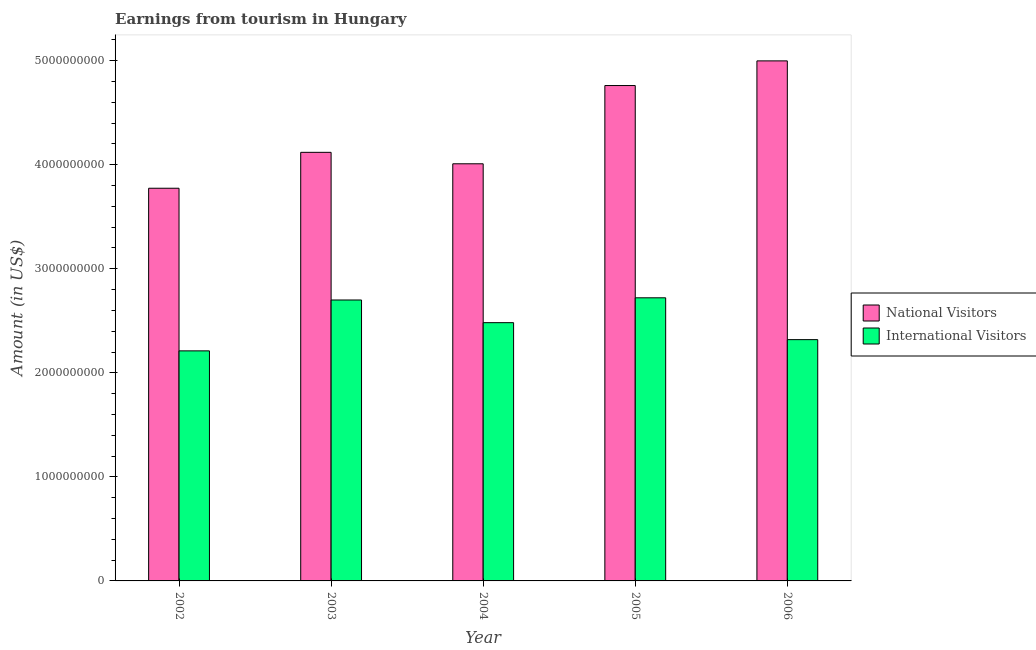Are the number of bars per tick equal to the number of legend labels?
Make the answer very short. Yes. Are the number of bars on each tick of the X-axis equal?
Offer a terse response. Yes. How many bars are there on the 4th tick from the left?
Your answer should be compact. 2. How many bars are there on the 3rd tick from the right?
Make the answer very short. 2. What is the label of the 2nd group of bars from the left?
Provide a short and direct response. 2003. What is the amount earned from international visitors in 2005?
Give a very brief answer. 2.72e+09. Across all years, what is the maximum amount earned from international visitors?
Your response must be concise. 2.72e+09. Across all years, what is the minimum amount earned from national visitors?
Keep it short and to the point. 3.77e+09. In which year was the amount earned from national visitors maximum?
Offer a very short reply. 2006. In which year was the amount earned from international visitors minimum?
Offer a very short reply. 2002. What is the total amount earned from national visitors in the graph?
Make the answer very short. 2.17e+1. What is the difference between the amount earned from international visitors in 2005 and that in 2006?
Provide a succinct answer. 4.02e+08. What is the difference between the amount earned from international visitors in 2003 and the amount earned from national visitors in 2005?
Make the answer very short. -2.10e+07. What is the average amount earned from international visitors per year?
Keep it short and to the point. 2.49e+09. What is the ratio of the amount earned from international visitors in 2002 to that in 2006?
Give a very brief answer. 0.95. What is the difference between the highest and the second highest amount earned from international visitors?
Make the answer very short. 2.10e+07. What is the difference between the highest and the lowest amount earned from international visitors?
Your response must be concise. 5.10e+08. In how many years, is the amount earned from national visitors greater than the average amount earned from national visitors taken over all years?
Provide a short and direct response. 2. What does the 1st bar from the left in 2004 represents?
Your answer should be compact. National Visitors. What does the 1st bar from the right in 2005 represents?
Provide a succinct answer. International Visitors. How many bars are there?
Make the answer very short. 10. Are all the bars in the graph horizontal?
Offer a terse response. No. How many years are there in the graph?
Offer a terse response. 5. Does the graph contain any zero values?
Provide a short and direct response. No. Where does the legend appear in the graph?
Ensure brevity in your answer.  Center right. How many legend labels are there?
Provide a short and direct response. 2. How are the legend labels stacked?
Provide a succinct answer. Vertical. What is the title of the graph?
Offer a terse response. Earnings from tourism in Hungary. Does "Lower secondary education" appear as one of the legend labels in the graph?
Provide a succinct answer. No. What is the Amount (in US$) in National Visitors in 2002?
Your answer should be very brief. 3.77e+09. What is the Amount (in US$) of International Visitors in 2002?
Provide a succinct answer. 2.21e+09. What is the Amount (in US$) of National Visitors in 2003?
Provide a succinct answer. 4.12e+09. What is the Amount (in US$) in International Visitors in 2003?
Provide a short and direct response. 2.70e+09. What is the Amount (in US$) of National Visitors in 2004?
Your response must be concise. 4.01e+09. What is the Amount (in US$) in International Visitors in 2004?
Keep it short and to the point. 2.48e+09. What is the Amount (in US$) of National Visitors in 2005?
Make the answer very short. 4.76e+09. What is the Amount (in US$) in International Visitors in 2005?
Provide a short and direct response. 2.72e+09. What is the Amount (in US$) of National Visitors in 2006?
Your answer should be very brief. 5.00e+09. What is the Amount (in US$) of International Visitors in 2006?
Offer a terse response. 2.32e+09. Across all years, what is the maximum Amount (in US$) in National Visitors?
Your response must be concise. 5.00e+09. Across all years, what is the maximum Amount (in US$) in International Visitors?
Your answer should be compact. 2.72e+09. Across all years, what is the minimum Amount (in US$) in National Visitors?
Provide a succinct answer. 3.77e+09. Across all years, what is the minimum Amount (in US$) of International Visitors?
Make the answer very short. 2.21e+09. What is the total Amount (in US$) in National Visitors in the graph?
Your response must be concise. 2.17e+1. What is the total Amount (in US$) in International Visitors in the graph?
Ensure brevity in your answer.  1.24e+1. What is the difference between the Amount (in US$) of National Visitors in 2002 and that in 2003?
Provide a succinct answer. -3.45e+08. What is the difference between the Amount (in US$) in International Visitors in 2002 and that in 2003?
Keep it short and to the point. -4.89e+08. What is the difference between the Amount (in US$) in National Visitors in 2002 and that in 2004?
Offer a very short reply. -2.35e+08. What is the difference between the Amount (in US$) of International Visitors in 2002 and that in 2004?
Keep it short and to the point. -2.71e+08. What is the difference between the Amount (in US$) in National Visitors in 2002 and that in 2005?
Provide a succinct answer. -9.87e+08. What is the difference between the Amount (in US$) of International Visitors in 2002 and that in 2005?
Offer a terse response. -5.10e+08. What is the difference between the Amount (in US$) in National Visitors in 2002 and that in 2006?
Offer a very short reply. -1.22e+09. What is the difference between the Amount (in US$) of International Visitors in 2002 and that in 2006?
Your response must be concise. -1.08e+08. What is the difference between the Amount (in US$) of National Visitors in 2003 and that in 2004?
Your response must be concise. 1.10e+08. What is the difference between the Amount (in US$) of International Visitors in 2003 and that in 2004?
Make the answer very short. 2.18e+08. What is the difference between the Amount (in US$) of National Visitors in 2003 and that in 2005?
Make the answer very short. -6.42e+08. What is the difference between the Amount (in US$) of International Visitors in 2003 and that in 2005?
Provide a short and direct response. -2.10e+07. What is the difference between the Amount (in US$) of National Visitors in 2003 and that in 2006?
Make the answer very short. -8.79e+08. What is the difference between the Amount (in US$) in International Visitors in 2003 and that in 2006?
Your answer should be very brief. 3.81e+08. What is the difference between the Amount (in US$) of National Visitors in 2004 and that in 2005?
Offer a very short reply. -7.52e+08. What is the difference between the Amount (in US$) in International Visitors in 2004 and that in 2005?
Ensure brevity in your answer.  -2.39e+08. What is the difference between the Amount (in US$) in National Visitors in 2004 and that in 2006?
Make the answer very short. -9.89e+08. What is the difference between the Amount (in US$) of International Visitors in 2004 and that in 2006?
Make the answer very short. 1.63e+08. What is the difference between the Amount (in US$) in National Visitors in 2005 and that in 2006?
Offer a terse response. -2.37e+08. What is the difference between the Amount (in US$) in International Visitors in 2005 and that in 2006?
Offer a very short reply. 4.02e+08. What is the difference between the Amount (in US$) of National Visitors in 2002 and the Amount (in US$) of International Visitors in 2003?
Ensure brevity in your answer.  1.07e+09. What is the difference between the Amount (in US$) in National Visitors in 2002 and the Amount (in US$) in International Visitors in 2004?
Offer a terse response. 1.29e+09. What is the difference between the Amount (in US$) in National Visitors in 2002 and the Amount (in US$) in International Visitors in 2005?
Provide a succinct answer. 1.05e+09. What is the difference between the Amount (in US$) in National Visitors in 2002 and the Amount (in US$) in International Visitors in 2006?
Keep it short and to the point. 1.46e+09. What is the difference between the Amount (in US$) in National Visitors in 2003 and the Amount (in US$) in International Visitors in 2004?
Keep it short and to the point. 1.64e+09. What is the difference between the Amount (in US$) of National Visitors in 2003 and the Amount (in US$) of International Visitors in 2005?
Offer a terse response. 1.40e+09. What is the difference between the Amount (in US$) in National Visitors in 2003 and the Amount (in US$) in International Visitors in 2006?
Give a very brief answer. 1.80e+09. What is the difference between the Amount (in US$) in National Visitors in 2004 and the Amount (in US$) in International Visitors in 2005?
Provide a short and direct response. 1.29e+09. What is the difference between the Amount (in US$) of National Visitors in 2004 and the Amount (in US$) of International Visitors in 2006?
Your answer should be compact. 1.69e+09. What is the difference between the Amount (in US$) in National Visitors in 2005 and the Amount (in US$) in International Visitors in 2006?
Give a very brief answer. 2.44e+09. What is the average Amount (in US$) in National Visitors per year?
Your response must be concise. 4.33e+09. What is the average Amount (in US$) of International Visitors per year?
Ensure brevity in your answer.  2.49e+09. In the year 2002, what is the difference between the Amount (in US$) in National Visitors and Amount (in US$) in International Visitors?
Your answer should be compact. 1.56e+09. In the year 2003, what is the difference between the Amount (in US$) in National Visitors and Amount (in US$) in International Visitors?
Your response must be concise. 1.42e+09. In the year 2004, what is the difference between the Amount (in US$) in National Visitors and Amount (in US$) in International Visitors?
Offer a terse response. 1.53e+09. In the year 2005, what is the difference between the Amount (in US$) of National Visitors and Amount (in US$) of International Visitors?
Ensure brevity in your answer.  2.04e+09. In the year 2006, what is the difference between the Amount (in US$) in National Visitors and Amount (in US$) in International Visitors?
Keep it short and to the point. 2.68e+09. What is the ratio of the Amount (in US$) of National Visitors in 2002 to that in 2003?
Give a very brief answer. 0.92. What is the ratio of the Amount (in US$) of International Visitors in 2002 to that in 2003?
Your answer should be compact. 0.82. What is the ratio of the Amount (in US$) in National Visitors in 2002 to that in 2004?
Keep it short and to the point. 0.94. What is the ratio of the Amount (in US$) in International Visitors in 2002 to that in 2004?
Make the answer very short. 0.89. What is the ratio of the Amount (in US$) of National Visitors in 2002 to that in 2005?
Make the answer very short. 0.79. What is the ratio of the Amount (in US$) in International Visitors in 2002 to that in 2005?
Your answer should be compact. 0.81. What is the ratio of the Amount (in US$) of National Visitors in 2002 to that in 2006?
Make the answer very short. 0.76. What is the ratio of the Amount (in US$) of International Visitors in 2002 to that in 2006?
Provide a short and direct response. 0.95. What is the ratio of the Amount (in US$) in National Visitors in 2003 to that in 2004?
Provide a succinct answer. 1.03. What is the ratio of the Amount (in US$) in International Visitors in 2003 to that in 2004?
Offer a very short reply. 1.09. What is the ratio of the Amount (in US$) of National Visitors in 2003 to that in 2005?
Make the answer very short. 0.87. What is the ratio of the Amount (in US$) in International Visitors in 2003 to that in 2005?
Offer a very short reply. 0.99. What is the ratio of the Amount (in US$) of National Visitors in 2003 to that in 2006?
Your response must be concise. 0.82. What is the ratio of the Amount (in US$) of International Visitors in 2003 to that in 2006?
Provide a succinct answer. 1.16. What is the ratio of the Amount (in US$) of National Visitors in 2004 to that in 2005?
Your response must be concise. 0.84. What is the ratio of the Amount (in US$) of International Visitors in 2004 to that in 2005?
Offer a terse response. 0.91. What is the ratio of the Amount (in US$) of National Visitors in 2004 to that in 2006?
Keep it short and to the point. 0.8. What is the ratio of the Amount (in US$) of International Visitors in 2004 to that in 2006?
Provide a short and direct response. 1.07. What is the ratio of the Amount (in US$) of National Visitors in 2005 to that in 2006?
Make the answer very short. 0.95. What is the ratio of the Amount (in US$) in International Visitors in 2005 to that in 2006?
Your answer should be compact. 1.17. What is the difference between the highest and the second highest Amount (in US$) of National Visitors?
Provide a short and direct response. 2.37e+08. What is the difference between the highest and the second highest Amount (in US$) of International Visitors?
Your answer should be compact. 2.10e+07. What is the difference between the highest and the lowest Amount (in US$) of National Visitors?
Give a very brief answer. 1.22e+09. What is the difference between the highest and the lowest Amount (in US$) in International Visitors?
Keep it short and to the point. 5.10e+08. 